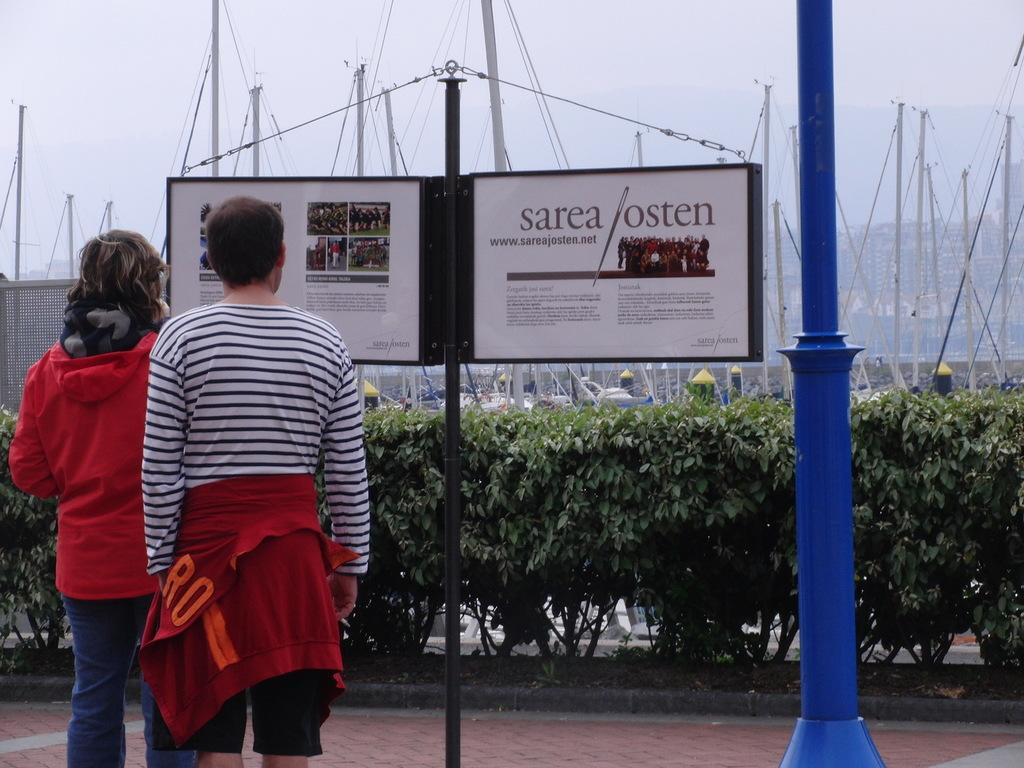How many people are in the image? There are two persons standing on the left side of the image. What can be seen between the two people? There is a pole with boards in the image. Are there any other poles visible in the image? Yes, there is another pole on the right side of the image. What type of vegetation is visible in the background of the image? Bushes are present in the background of the image. What else can be seen in the background of the image? Poles and the sky are visible in the background of the image. What type of fowl is perched on the pole with boards in the image? There are no fowl present on the pole with boards in the image. Is there a doctor attending to the people in the image? There is no doctor present in the image. 